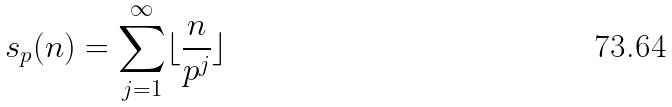<formula> <loc_0><loc_0><loc_500><loc_500>s _ { p } ( n ) = \sum _ { j = 1 } ^ { \infty } \lfloor \frac { n } { p ^ { j } } \rfloor</formula> 